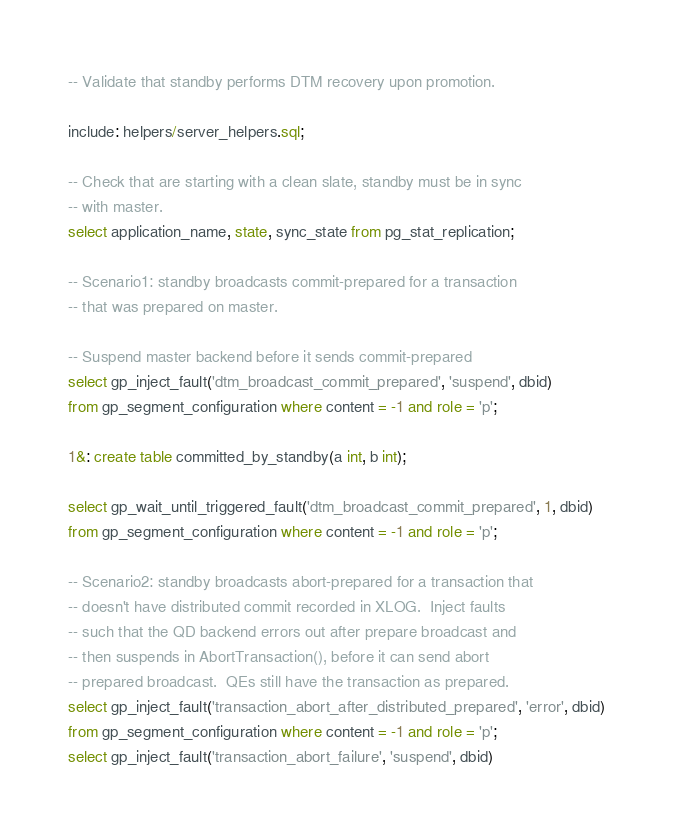Convert code to text. <code><loc_0><loc_0><loc_500><loc_500><_SQL_>-- Validate that standby performs DTM recovery upon promotion.

include: helpers/server_helpers.sql;

-- Check that are starting with a clean slate, standby must be in sync
-- with master.
select application_name, state, sync_state from pg_stat_replication;

-- Scenario1: standby broadcasts commit-prepared for a transaction
-- that was prepared on master.

-- Suspend master backend before it sends commit-prepared
select gp_inject_fault('dtm_broadcast_commit_prepared', 'suspend', dbid)
from gp_segment_configuration where content = -1 and role = 'p';

1&: create table committed_by_standby(a int, b int);

select gp_wait_until_triggered_fault('dtm_broadcast_commit_prepared', 1, dbid)
from gp_segment_configuration where content = -1 and role = 'p';

-- Scenario2: standby broadcasts abort-prepared for a transaction that
-- doesn't have distributed commit recorded in XLOG.  Inject faults
-- such that the QD backend errors out after prepare broadcast and
-- then suspends in AbortTransaction(), before it can send abort
-- prepared broadcast.  QEs still have the transaction as prepared.
select gp_inject_fault('transaction_abort_after_distributed_prepared', 'error', dbid)
from gp_segment_configuration where content = -1 and role = 'p';
select gp_inject_fault('transaction_abort_failure', 'suspend', dbid)</code> 